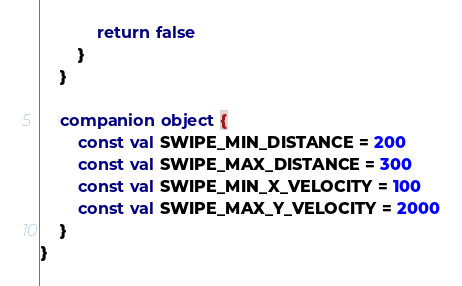<code> <loc_0><loc_0><loc_500><loc_500><_Kotlin_>            return false
        }
    }

    companion object {
        const val SWIPE_MIN_DISTANCE = 200
        const val SWIPE_MAX_DISTANCE = 300
        const val SWIPE_MIN_X_VELOCITY = 100
        const val SWIPE_MAX_Y_VELOCITY = 2000
    }
}
</code> 